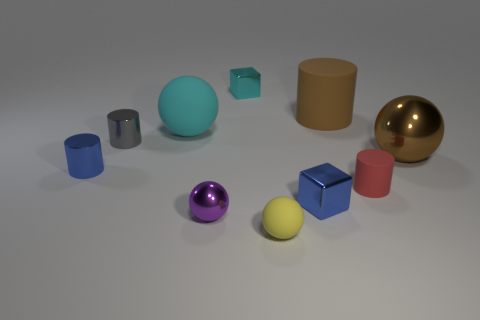Subtract all cyan cylinders. Subtract all purple blocks. How many cylinders are left? 4 Subtract all cylinders. How many objects are left? 6 Add 7 large cyan things. How many large cyan things exist? 8 Subtract 0 red balls. How many objects are left? 10 Subtract all small yellow matte objects. Subtract all cyan balls. How many objects are left? 8 Add 9 purple things. How many purple things are left? 10 